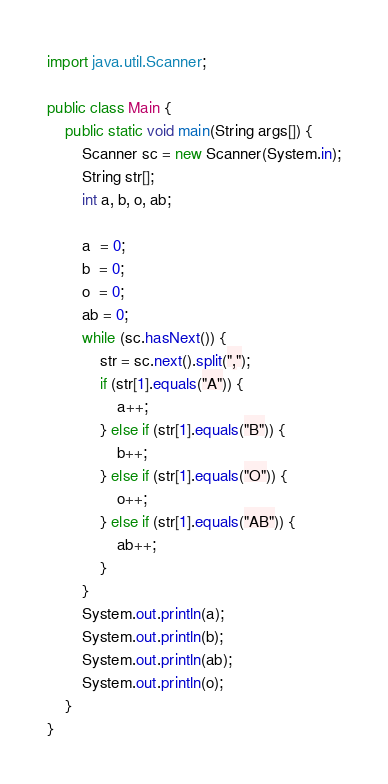<code> <loc_0><loc_0><loc_500><loc_500><_Java_>import java.util.Scanner;

public class Main {
	public static void main(String args[]) {
		Scanner sc = new Scanner(System.in);
		String str[];
		int a, b, o, ab;

		a  = 0;
		b  = 0;
		o  = 0;
		ab = 0;
		while (sc.hasNext()) {
			str = sc.next().split(",");
			if (str[1].equals("A")) {
				a++;
			} else if (str[1].equals("B")) {
				b++;
			} else if (str[1].equals("O")) {
				o++;
			} else if (str[1].equals("AB")) {
				ab++;
			}
		}
		System.out.println(a);
		System.out.println(b);
		System.out.println(ab);
		System.out.println(o);
	}
}</code> 